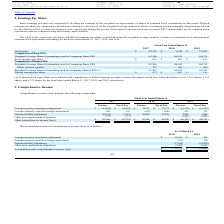According to Avx Corporation's financial document, What is the net income in the fiscal year ended March 31, 2017? According to the financial document, $125,785. The relevant text states: "Net income $ 125,785 $ 4,910 $ 271,813..." Also, What is the net income in the fiscal year ended March 31, 2018? According to the financial document, $4,910. The relevant text states: "Net income $ 125,785 $ 4,910 $ 271,813..." Also, What is the net income in the fiscal year ended March 31, 2019? According to the financial document, $271,813. The relevant text states: "Net income $ 125,785 $ 4,910 $ 271,813..." Also, can you calculate: What is the total number of weighted average shares outstanding used in computing diluted EPS in 2017 and 2018? Based on the calculation: 167,837 + 168,925 , the result is 336762. This is based on the information: "res Outstanding used in Computing Diluted EPS (1) 167,837 168,925 169,322 tanding used in Computing Diluted EPS (1) 167,837 168,925 169,322..." The key data points involved are: 167,837, 168,925. Also, can you calculate: What is the percentage of common stock equivalents not included in the computation of diluted earnings as a percentage of the weighted average shares outstanding used in computing diluted EPS in 2019? Based on the calculation: 4,375/169,322 , the result is 2.58 (percentage). This is based on the information: "used in Computing Diluted EPS (1) 167,837 168,925 169,322 nti-dilutive were 1,381 shares, 1,733 shares, and 4,375 shares for the fiscal years ended March 31, 2017, 2018, and 2019, respectively. 3. Com..." The key data points involved are: 169,322, 4,375. Also, can you calculate: What is the sum of the weighted average shares outstanding used in computing diluted EPS and the common stock equivalents not included in 2018? Based on the calculation: 168,925 + 1,733 , the result is 170658. This is based on the information: "tanding used in Computing Diluted EPS (1) 167,837 168,925 169,322 would have been anti-dilutive were 1,381 shares, 1,733 shares, and 4,375 shares for the fiscal years ended March 31, 2017, 2018, and 2..." The key data points involved are: 1,733, 168,925. 